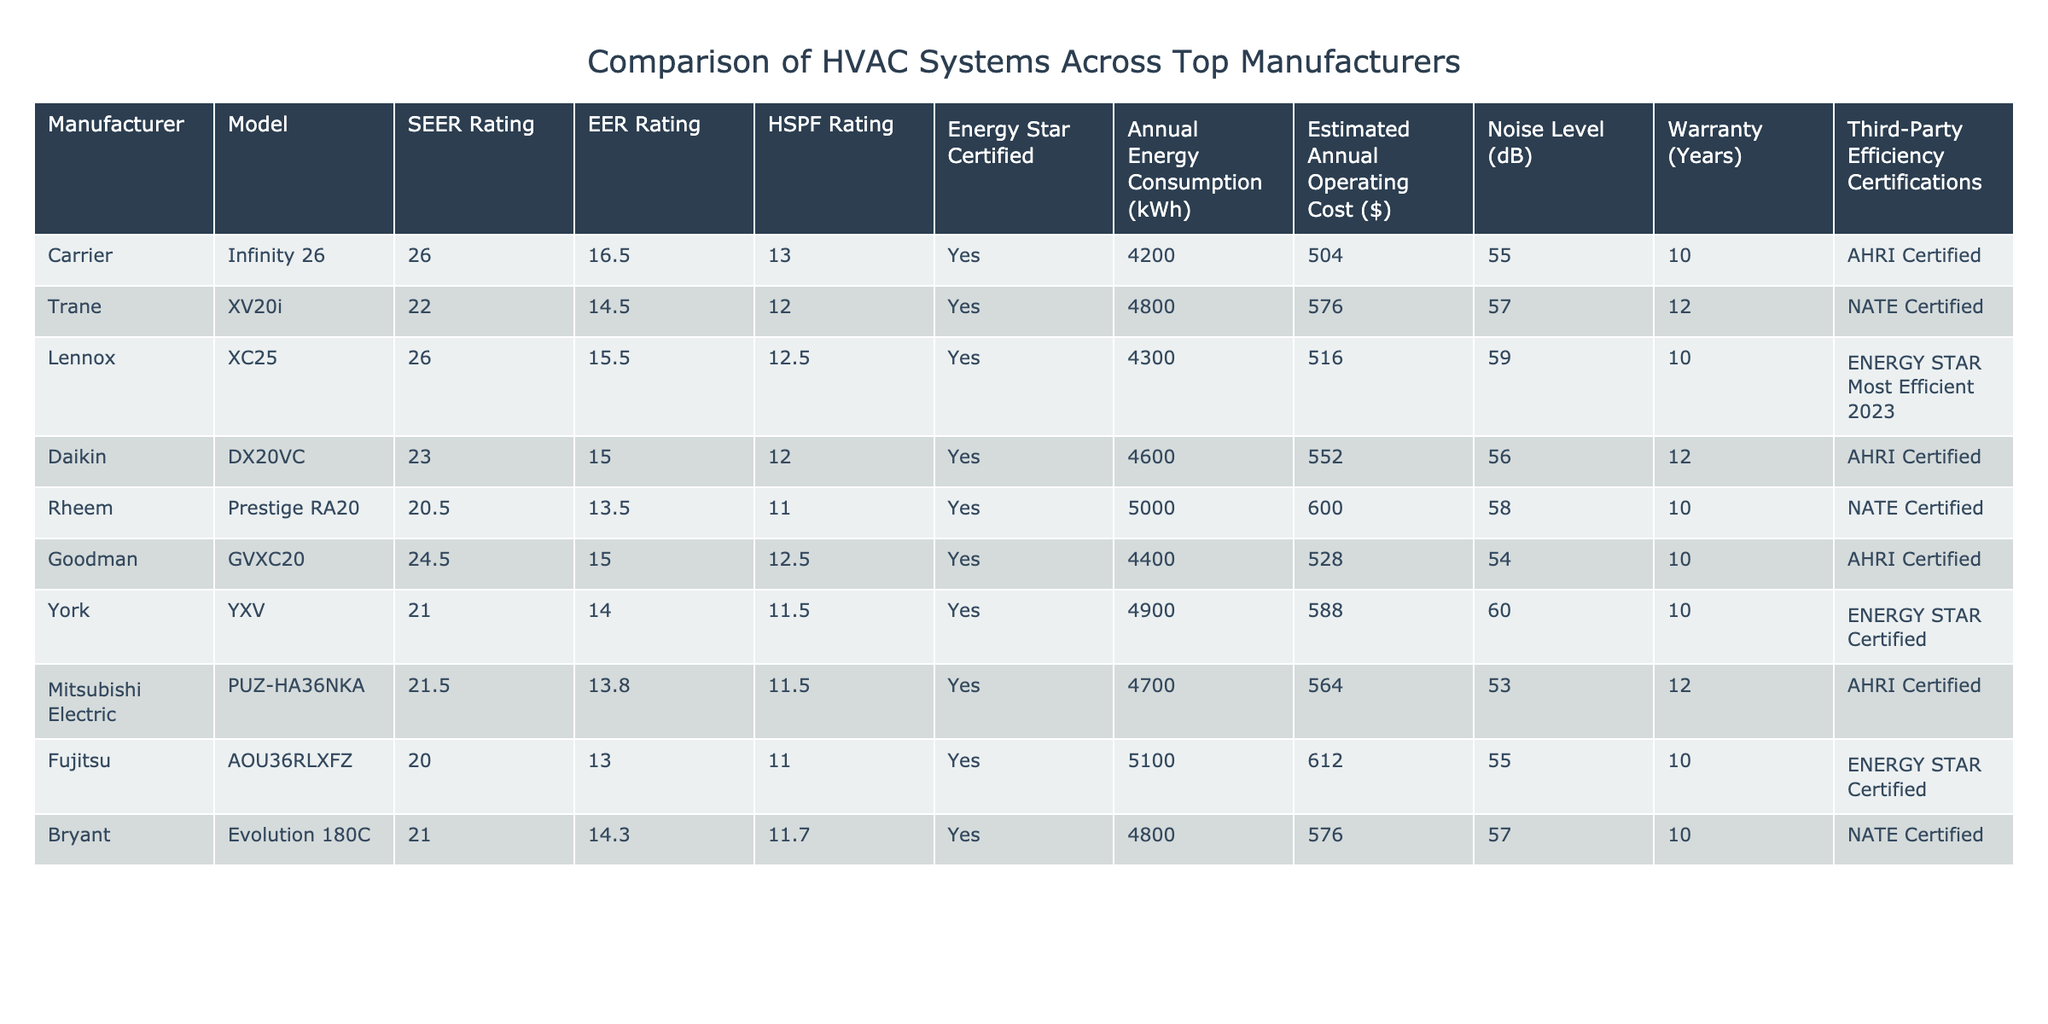What is the SEER rating of the Carrier Infinity 26 model? The SEER rating is specifically listed in the table under the Carrier Infinity 26 row. The value directly presented is 26.
Answer: 26 Which model has the lowest EER rating? The lowest EER rating can be found by comparing the EER ratings across different models in the table. The Rheem Prestige RA20 has the lowest EER rating of 13.5.
Answer: 13.5 Are all the listed models Energy Star certified? Reviewing the Energy Star Certified column, all models have "Yes" confirmed, indicating they are all Energy Star certified.
Answer: Yes What is the difference in annual energy consumption between the Lennox XC25 and the Fujitsu AOU36RLXFZ models? The annual energy consumption for Lennox XC25 is 4300 kWh, and for Fujitsu AOU36RLXFZ, it is 5100 kWh. The difference in consumption is 5100 - 4300 = 800 kWh.
Answer: 800 kWh Which manufacturer has a warranty of 12 years and what model is it? Looking across the Warranty column, Daikin DX20VC and Mitsubishi Electric PUZ-HA36NKA both have a warranty of 12 years. The corresponding manufacturers are Daikin and Mitsubishi Electric.
Answer: Daikin and Mitsubishi Electric What is the estimated annual operating cost for the model with the highest HSPF rating? The model with the highest HSPF rating is the Carrier Infinity 26, which has an HSPF of 13. Its estimated annual operating cost listed is $504.
Answer: $504 How many models have a noise level below 55 dB? Reviewing the Noise Level column, the models with noise levels below 55 dB are: Carrier Infinity 26 (55), Goodman GVXC20 (54), and Mitsubishi Electric PUZ-HA36NKA (53). Only Goodman GVXC20 and Mitsubishi Electric PUZ-HA36NKA have noise levels below 55 dB, totaling 2 models.
Answer: 2 models What is the average SEER rating for all models listed? The SEER ratings for all models are: 26, 22, 26, 23, 20.5, 24.5, 21, 21.5, and 20. To find the average, sum these values: 26 + 22 + 26 + 23 + 20.5 + 24.5 + 21 + 21.5 + 20 =  214. Dividing by the number of models (9), the average SEER rating is 214/9 ≈ 23.78.
Answer: 23.78 Which model has the highest number of third-party efficiency certifications? The table indicates that Carrier Infinity 26 holds the AHRI Certified label only. All other models have either NATE Certified or ENERGY STAR Most Efficient labels, but none exceed one certification, making Carrier the unique holder of one certification.
Answer: One certification 